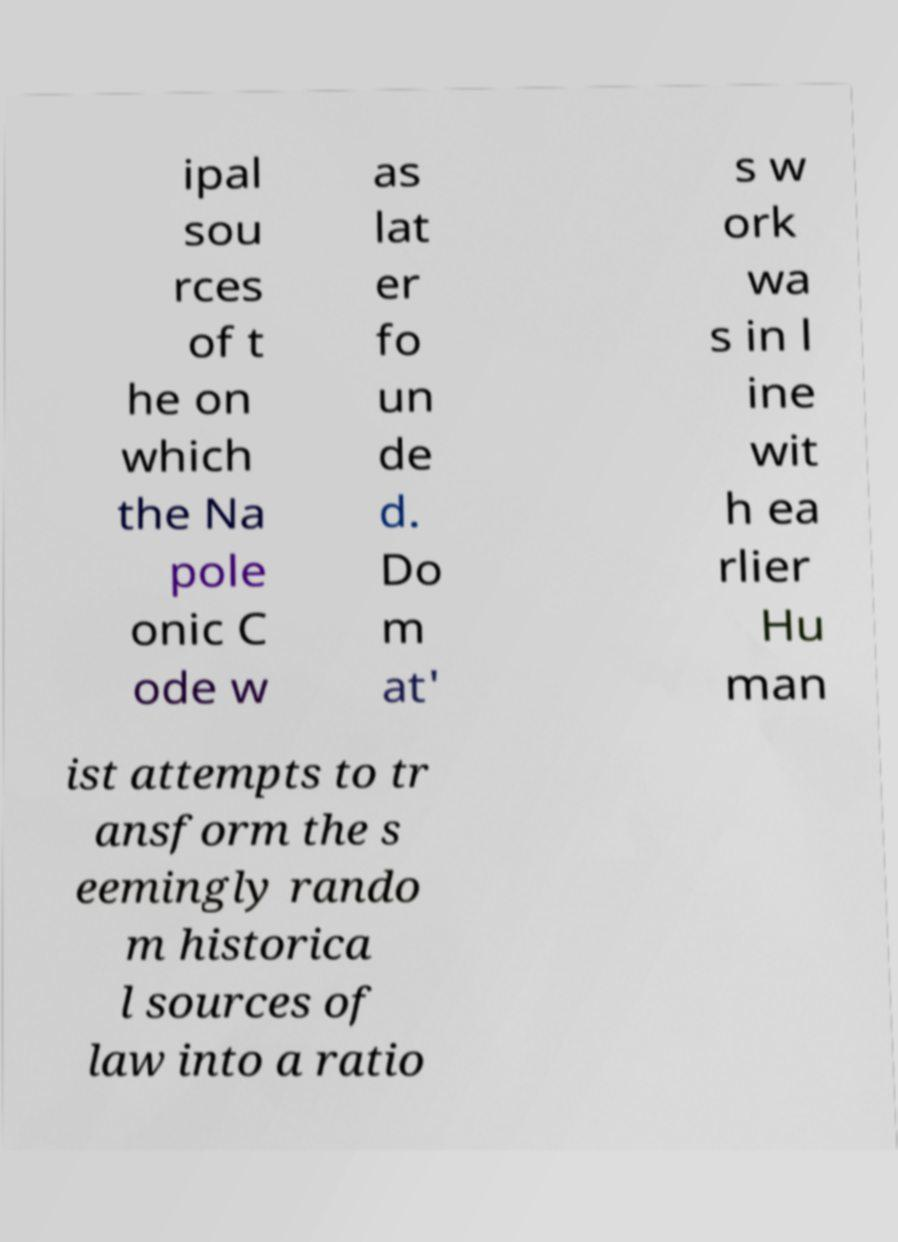Can you accurately transcribe the text from the provided image for me? ipal sou rces of t he on which the Na pole onic C ode w as lat er fo un de d. Do m at' s w ork wa s in l ine wit h ea rlier Hu man ist attempts to tr ansform the s eemingly rando m historica l sources of law into a ratio 